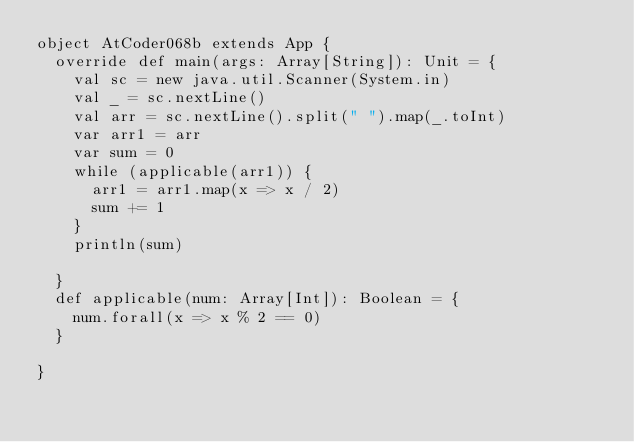<code> <loc_0><loc_0><loc_500><loc_500><_Scala_>object AtCoder068b extends App {
  override def main(args: Array[String]): Unit = {
    val sc = new java.util.Scanner(System.in)
    val _ = sc.nextLine()
    val arr = sc.nextLine().split(" ").map(_.toInt)
    var arr1 = arr
    var sum = 0
    while (applicable(arr1)) {
      arr1 = arr1.map(x => x / 2)
      sum += 1
    }
    println(sum)

  }
  def applicable(num: Array[Int]): Boolean = {
    num.forall(x => x % 2 == 0)
  }

}</code> 